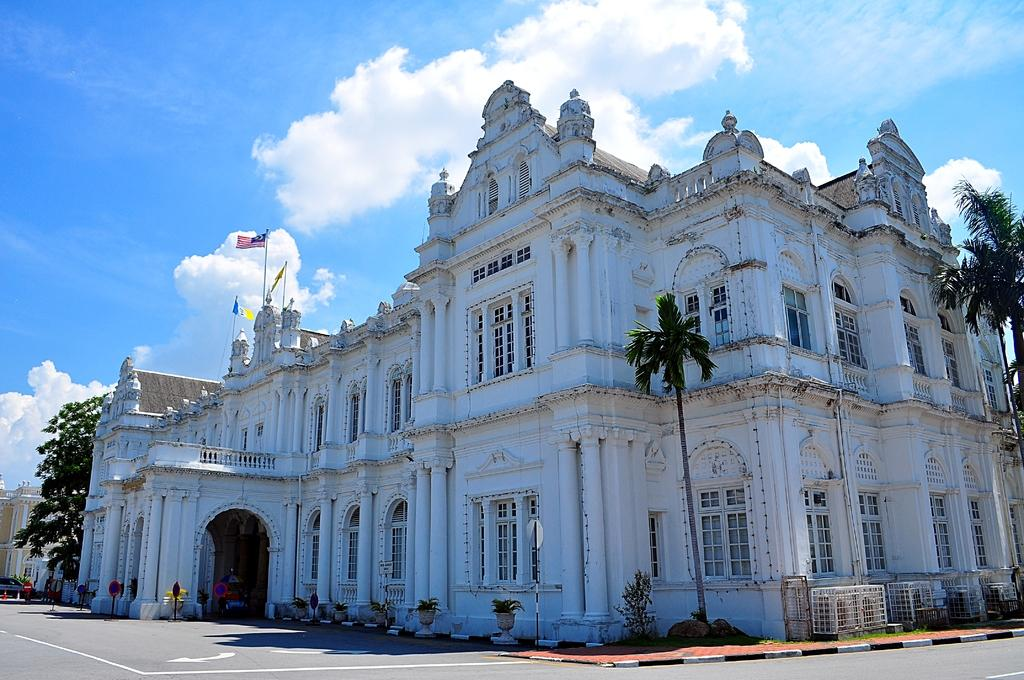What is in the foreground of the image? There is a road in the foreground of the image. What type of trees can be seen in the image? There are palm trees and other trees in the image. What other types of vegetation are present in the image? There are plants in the image. What architectural feature can be seen in the image? There are windows in the image. What symbolic objects are present in the image? There are flags in the image. What type of structure is visible in the image? There is a building in the image. On which side of the image is the building located? The building is on the left side of the image. What is the weather like in the image? The sky is sunny in the image. What type of hat is the rose wearing in the image? There is no hat or rose present in the image. What organization is represented by the flags in the image? The flags in the image do not represent any specific organization; they are simply symbolic objects. 